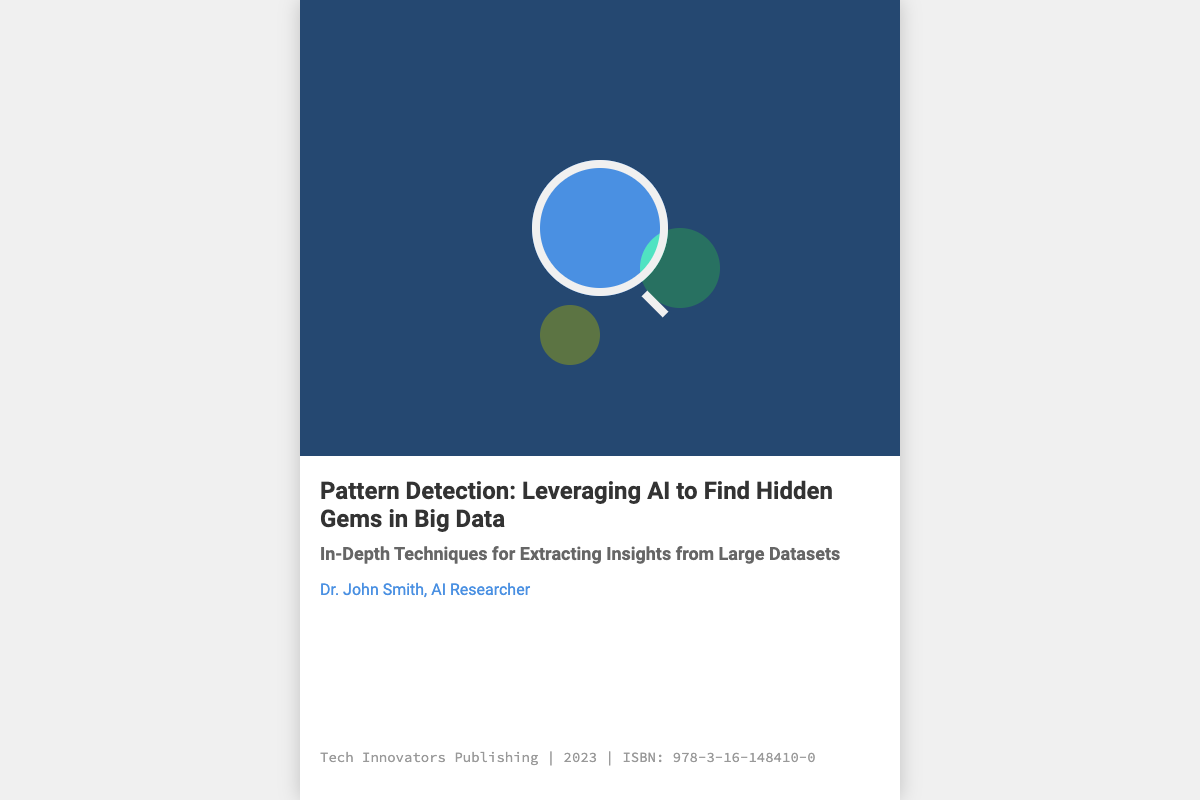What is the title of the book? The title of the book is prominently displayed on the cover.
Answer: Pattern Detection: Leveraging AI to Find Hidden Gems in Big Data Who is the author of the book? The author's name is mentioned in the cover text area.
Answer: Dr. John Smith What is the subtitle of the book? The subtitle provides additional context about the content of the book.
Answer: In-Depth Techniques for Extracting Insights from Large Datasets What is the publisher's name? The publisher's name is included at the bottom of the cover.
Answer: Tech Innovators Publishing What year was the book published? The publication year is stated along with the publisher's details.
Answer: 2023 What is the ISBN number? The ISBN number is listed in the publication information.
Answer: 978-3-16-148410-0 What color is the background of the cover image? The background color of the cover image is important for visual presentation.
Answer: #4A90E2 How many nodes are displayed on the cover? The number of nodes can be found in the cover image section.
Answer: 3 What shape is the magnifying glass? The magnifying glass shape emphasizes detective work in the context of the book.
Answer: Circle 